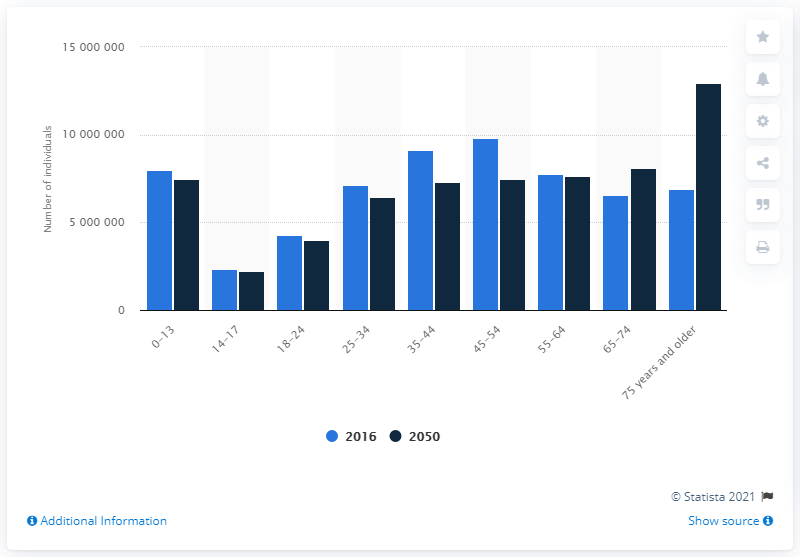List a handful of essential elements in this visual. By 2050, the number of people aged 65 and over in Italy is expected to increase to 7,457,328. 